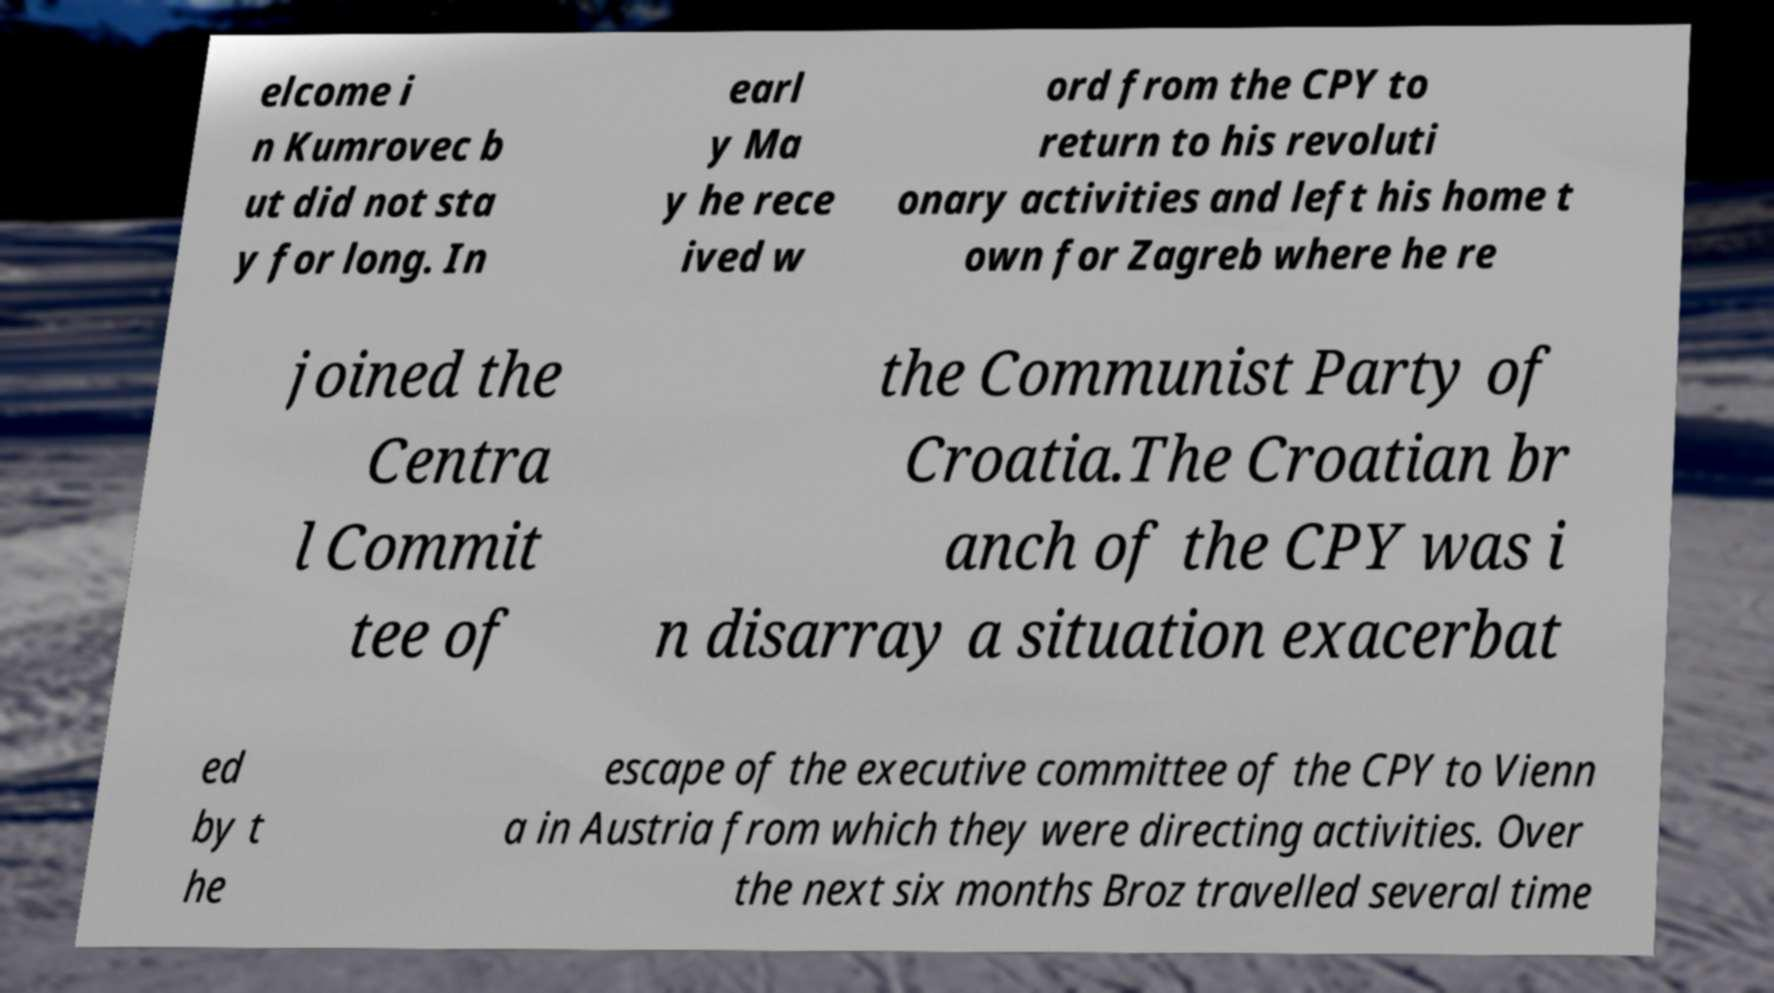I need the written content from this picture converted into text. Can you do that? elcome i n Kumrovec b ut did not sta y for long. In earl y Ma y he rece ived w ord from the CPY to return to his revoluti onary activities and left his home t own for Zagreb where he re joined the Centra l Commit tee of the Communist Party of Croatia.The Croatian br anch of the CPY was i n disarray a situation exacerbat ed by t he escape of the executive committee of the CPY to Vienn a in Austria from which they were directing activities. Over the next six months Broz travelled several time 